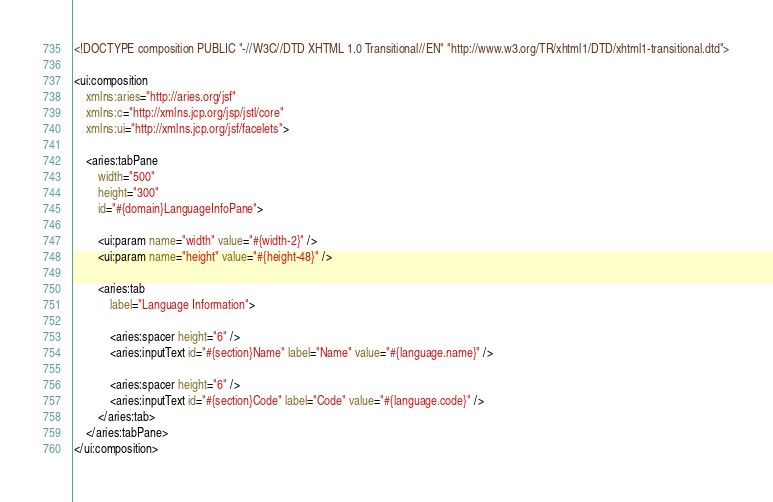Convert code to text. <code><loc_0><loc_0><loc_500><loc_500><_HTML_><!DOCTYPE composition PUBLIC "-//W3C//DTD XHTML 1.0 Transitional//EN" "http://www.w3.org/TR/xhtml1/DTD/xhtml1-transitional.dtd">

<ui:composition
	xmlns:aries="http://aries.org/jsf"
	xmlns:c="http://xmlns.jcp.org/jsp/jstl/core"
	xmlns:ui="http://xmlns.jcp.org/jsf/facelets">
	
	<aries:tabPane
		width="500"
		height="300"
		id="#{domain}LanguageInfoPane">
		
		<ui:param name="width" value="#{width-2}" />
		<ui:param name="height" value="#{height-48}" />
		
		<aries:tab
			label="Language Information">
			
			<aries:spacer height="6" />
			<aries:inputText id="#{section}Name" label="Name" value="#{language.name}" />
			
			<aries:spacer height="6" />
			<aries:inputText id="#{section}Code" label="Code" value="#{language.code}" />
		</aries:tab>
	</aries:tabPane>
</ui:composition>
</code> 